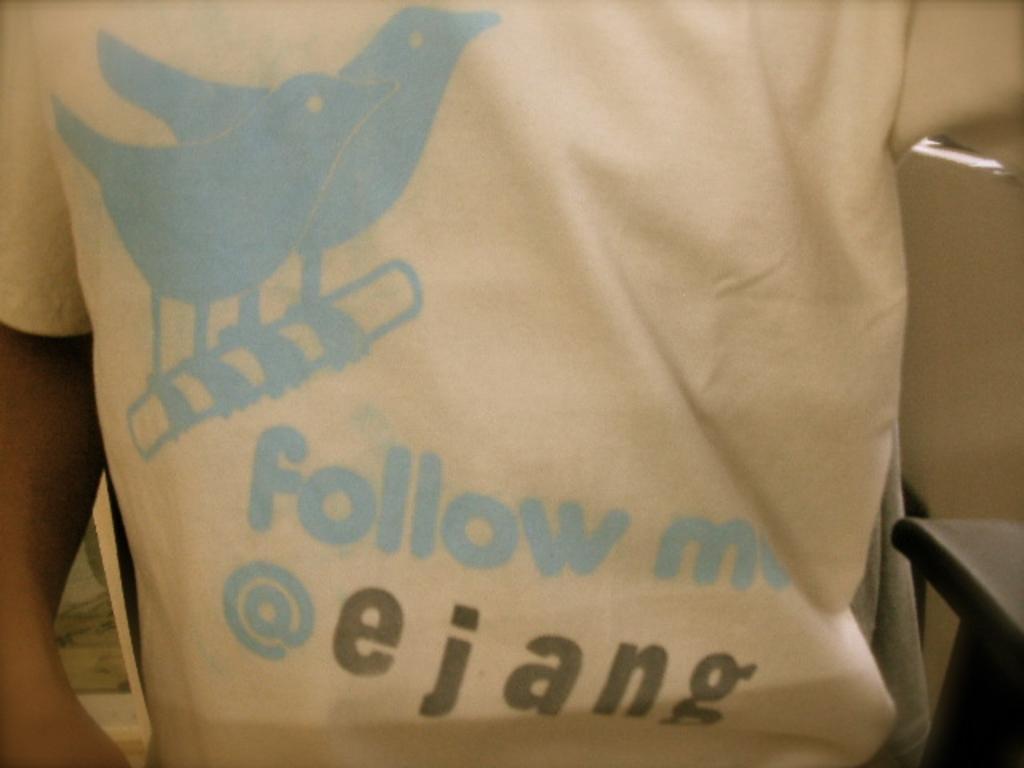Can you describe this image briefly? In this image in the foreground there is one person and he is wearing a t shirt, on the t shirt there is some text written. 